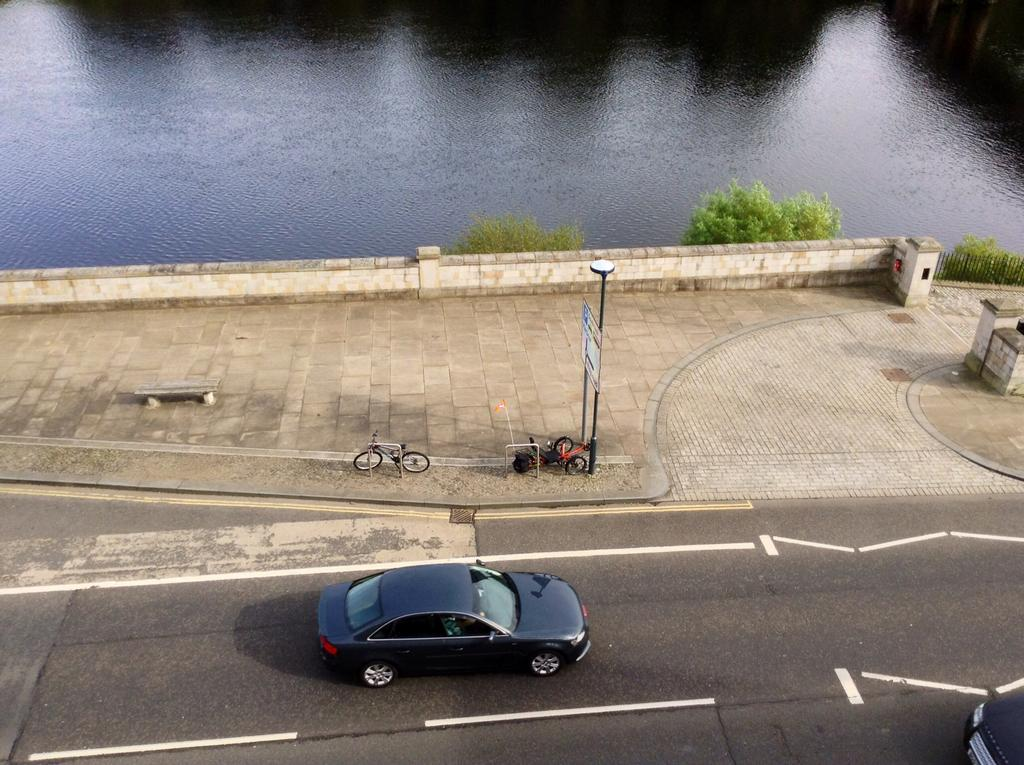What type of vehicle can be seen on the road in the image? There is a vehicle on the road in the image. What type of vehicle can be seen on the footpath in the image? There is a vehicle on the footpath in the image. What other object can be seen on the footpath in the image? There is a bicycle on the footpath in the image. What structure can be seen on the footpath in the image? There is a pole on the footpath in the image. What type of seating is present in the image? There is a bench in the image. What type of advertisement is present in the image? There is a hoarding in the image. What type of barrier is present in the image? There is: There is a fence in the image. What type of vegetation is present in the image? There are trees in the image. What natural element is visible in the image? There is water visible in the image. How many legs can be seen on the vehicle on the footpath in the image? Vehicles do not have legs, so this question cannot be answered. What is the distance between the vehicle on the road and the vehicle on the footpath in the image? The distance between the two vehicles cannot be determined from the image alone. 